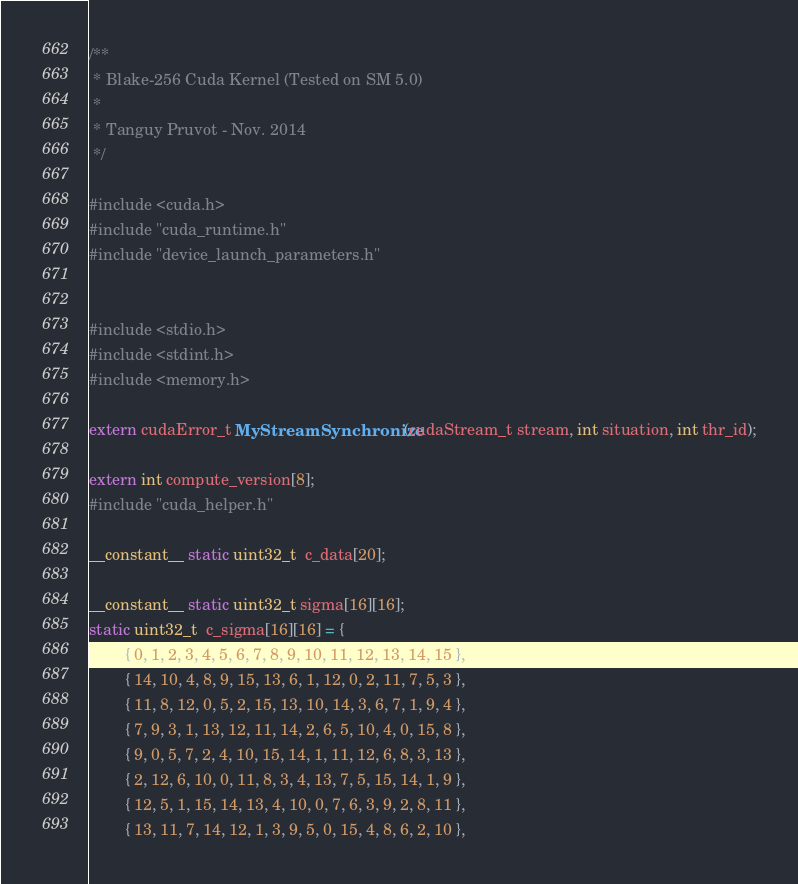Convert code to text. <code><loc_0><loc_0><loc_500><loc_500><_Cuda_>/**
 * Blake-256 Cuda Kernel (Tested on SM 5.0)
 *
 * Tanguy Pruvot - Nov. 2014
 */

#include <cuda.h>
#include "cuda_runtime.h"
#include "device_launch_parameters.h"


#include <stdio.h>
#include <stdint.h>
#include <memory.h>

extern cudaError_t MyStreamSynchronize(cudaStream_t stream, int situation, int thr_id);

extern int compute_version[8];
#include "cuda_helper.h"

__constant__ static uint32_t  c_data[20];

__constant__ static uint32_t sigma[16][16];
static uint32_t  c_sigma[16][16] = {
		{ 0, 1, 2, 3, 4, 5, 6, 7, 8, 9, 10, 11, 12, 13, 14, 15 },
		{ 14, 10, 4, 8, 9, 15, 13, 6, 1, 12, 0, 2, 11, 7, 5, 3 },
		{ 11, 8, 12, 0, 5, 2, 15, 13, 10, 14, 3, 6, 7, 1, 9, 4 },
		{ 7, 9, 3, 1, 13, 12, 11, 14, 2, 6, 5, 10, 4, 0, 15, 8 },
		{ 9, 0, 5, 7, 2, 4, 10, 15, 14, 1, 11, 12, 6, 8, 3, 13 },
		{ 2, 12, 6, 10, 0, 11, 8, 3, 4, 13, 7, 5, 15, 14, 1, 9 },
		{ 12, 5, 1, 15, 14, 13, 4, 10, 0, 7, 6, 3, 9, 2, 8, 11 },
		{ 13, 11, 7, 14, 12, 1, 3, 9, 5, 0, 15, 4, 8, 6, 2, 10 },</code> 